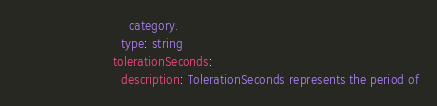Convert code to text. <code><loc_0><loc_0><loc_500><loc_500><_YAML_>                            category.
                          type: string
                        tolerationSeconds:
                          description: TolerationSeconds represents the period of</code> 